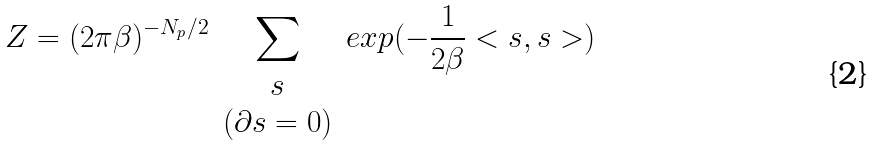Convert formula to latex. <formula><loc_0><loc_0><loc_500><loc_500>Z = ( 2 \pi \beta ) ^ { - N _ { p } / 2 } \sum _ { \begin{array} { c } s \\ ( \partial s = 0 ) \end{array} } e x p ( - \frac { 1 } { 2 \beta } < s , s > )</formula> 